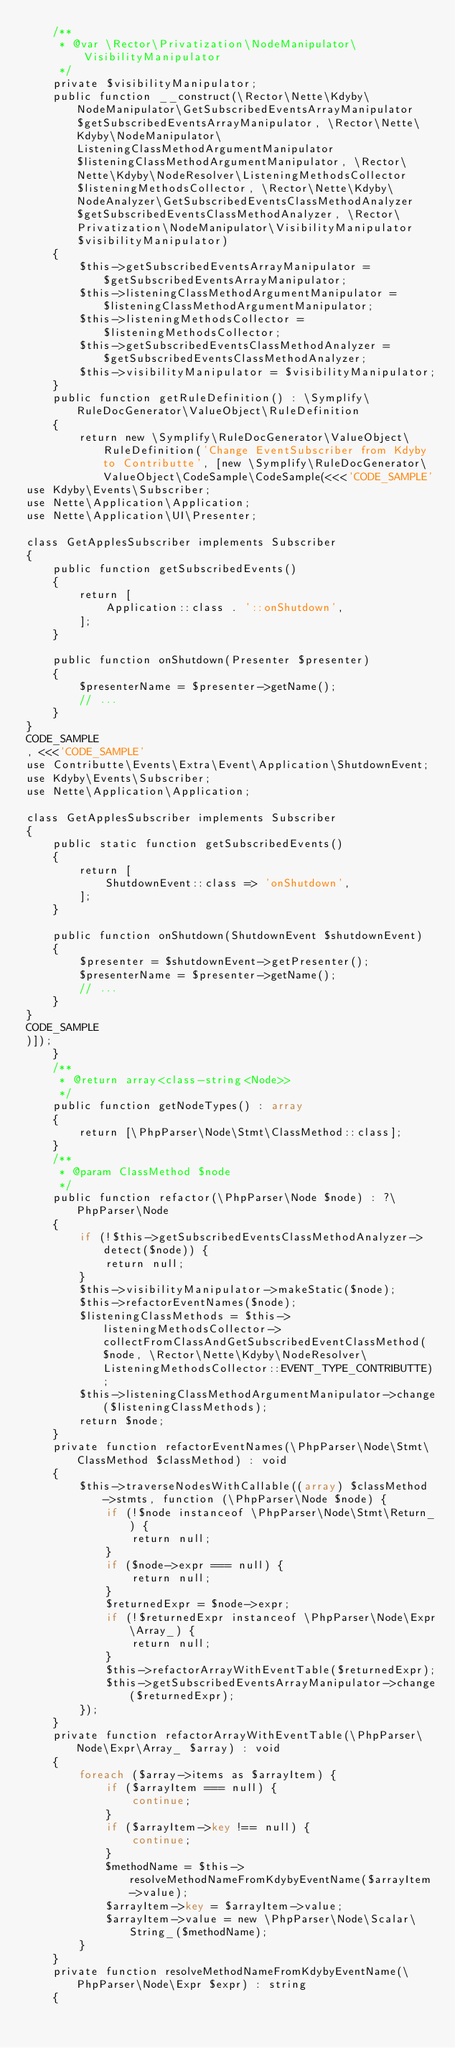<code> <loc_0><loc_0><loc_500><loc_500><_PHP_>    /**
     * @var \Rector\Privatization\NodeManipulator\VisibilityManipulator
     */
    private $visibilityManipulator;
    public function __construct(\Rector\Nette\Kdyby\NodeManipulator\GetSubscribedEventsArrayManipulator $getSubscribedEventsArrayManipulator, \Rector\Nette\Kdyby\NodeManipulator\ListeningClassMethodArgumentManipulator $listeningClassMethodArgumentManipulator, \Rector\Nette\Kdyby\NodeResolver\ListeningMethodsCollector $listeningMethodsCollector, \Rector\Nette\Kdyby\NodeAnalyzer\GetSubscribedEventsClassMethodAnalyzer $getSubscribedEventsClassMethodAnalyzer, \Rector\Privatization\NodeManipulator\VisibilityManipulator $visibilityManipulator)
    {
        $this->getSubscribedEventsArrayManipulator = $getSubscribedEventsArrayManipulator;
        $this->listeningClassMethodArgumentManipulator = $listeningClassMethodArgumentManipulator;
        $this->listeningMethodsCollector = $listeningMethodsCollector;
        $this->getSubscribedEventsClassMethodAnalyzer = $getSubscribedEventsClassMethodAnalyzer;
        $this->visibilityManipulator = $visibilityManipulator;
    }
    public function getRuleDefinition() : \Symplify\RuleDocGenerator\ValueObject\RuleDefinition
    {
        return new \Symplify\RuleDocGenerator\ValueObject\RuleDefinition('Change EventSubscriber from Kdyby to Contributte', [new \Symplify\RuleDocGenerator\ValueObject\CodeSample\CodeSample(<<<'CODE_SAMPLE'
use Kdyby\Events\Subscriber;
use Nette\Application\Application;
use Nette\Application\UI\Presenter;

class GetApplesSubscriber implements Subscriber
{
    public function getSubscribedEvents()
    {
        return [
            Application::class . '::onShutdown',
        ];
    }

    public function onShutdown(Presenter $presenter)
    {
        $presenterName = $presenter->getName();
        // ...
    }
}
CODE_SAMPLE
, <<<'CODE_SAMPLE'
use Contributte\Events\Extra\Event\Application\ShutdownEvent;
use Kdyby\Events\Subscriber;
use Nette\Application\Application;

class GetApplesSubscriber implements Subscriber
{
    public static function getSubscribedEvents()
    {
        return [
            ShutdownEvent::class => 'onShutdown',
        ];
    }

    public function onShutdown(ShutdownEvent $shutdownEvent)
    {
        $presenter = $shutdownEvent->getPresenter();
        $presenterName = $presenter->getName();
        // ...
    }
}
CODE_SAMPLE
)]);
    }
    /**
     * @return array<class-string<Node>>
     */
    public function getNodeTypes() : array
    {
        return [\PhpParser\Node\Stmt\ClassMethod::class];
    }
    /**
     * @param ClassMethod $node
     */
    public function refactor(\PhpParser\Node $node) : ?\PhpParser\Node
    {
        if (!$this->getSubscribedEventsClassMethodAnalyzer->detect($node)) {
            return null;
        }
        $this->visibilityManipulator->makeStatic($node);
        $this->refactorEventNames($node);
        $listeningClassMethods = $this->listeningMethodsCollector->collectFromClassAndGetSubscribedEventClassMethod($node, \Rector\Nette\Kdyby\NodeResolver\ListeningMethodsCollector::EVENT_TYPE_CONTRIBUTTE);
        $this->listeningClassMethodArgumentManipulator->change($listeningClassMethods);
        return $node;
    }
    private function refactorEventNames(\PhpParser\Node\Stmt\ClassMethod $classMethod) : void
    {
        $this->traverseNodesWithCallable((array) $classMethod->stmts, function (\PhpParser\Node $node) {
            if (!$node instanceof \PhpParser\Node\Stmt\Return_) {
                return null;
            }
            if ($node->expr === null) {
                return null;
            }
            $returnedExpr = $node->expr;
            if (!$returnedExpr instanceof \PhpParser\Node\Expr\Array_) {
                return null;
            }
            $this->refactorArrayWithEventTable($returnedExpr);
            $this->getSubscribedEventsArrayManipulator->change($returnedExpr);
        });
    }
    private function refactorArrayWithEventTable(\PhpParser\Node\Expr\Array_ $array) : void
    {
        foreach ($array->items as $arrayItem) {
            if ($arrayItem === null) {
                continue;
            }
            if ($arrayItem->key !== null) {
                continue;
            }
            $methodName = $this->resolveMethodNameFromKdybyEventName($arrayItem->value);
            $arrayItem->key = $arrayItem->value;
            $arrayItem->value = new \PhpParser\Node\Scalar\String_($methodName);
        }
    }
    private function resolveMethodNameFromKdybyEventName(\PhpParser\Node\Expr $expr) : string
    {</code> 